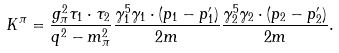<formula> <loc_0><loc_0><loc_500><loc_500>K ^ { \pi } = \frac { g _ { \pi } ^ { 2 } \tau _ { 1 } \cdot \tau _ { 2 } } { q ^ { 2 } - m _ { \pi } ^ { 2 } } \frac { \gamma _ { 1 } ^ { 5 } \gamma _ { 1 } \cdot ( p _ { 1 } - p ^ { \prime } _ { 1 } ) } { 2 m } \frac { \gamma _ { 2 } ^ { 5 } \gamma _ { 2 } \cdot ( p _ { 2 } - p ^ { \prime } _ { 2 } ) } { 2 m } .</formula> 